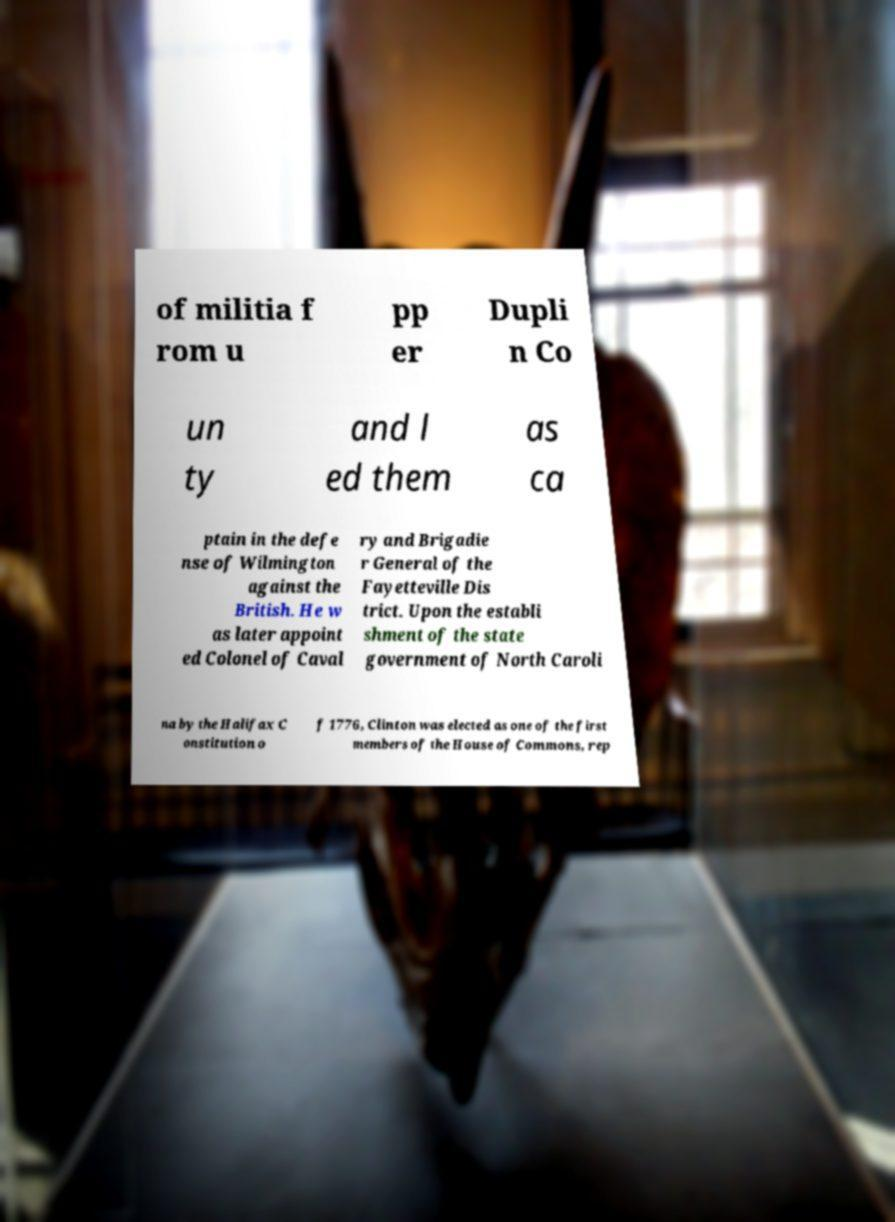Could you assist in decoding the text presented in this image and type it out clearly? of militia f rom u pp er Dupli n Co un ty and l ed them as ca ptain in the defe nse of Wilmington against the British. He w as later appoint ed Colonel of Caval ry and Brigadie r General of the Fayetteville Dis trict. Upon the establi shment of the state government of North Caroli na by the Halifax C onstitution o f 1776, Clinton was elected as one of the first members of the House of Commons, rep 